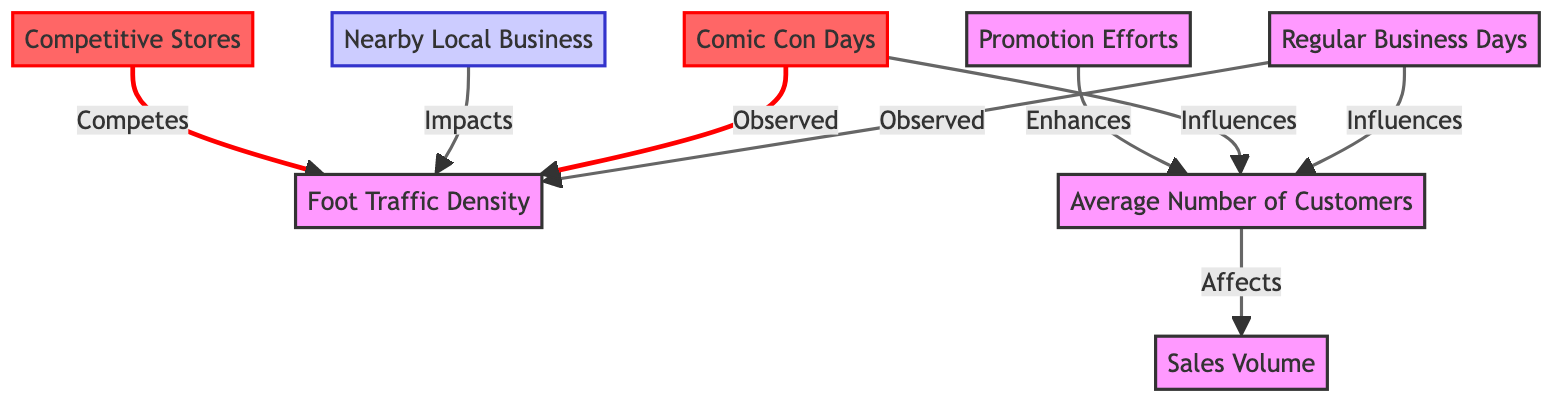What are the two main categories of days illustrated in the diagram? The diagram clearly distinguishes between "Regular Business Days" and "Comic Con Days" as the main categories affecting foot traffic density. These two nodes are the starting points that influence other aspects in the diagram.
Answer: Regular Business Days, Comic Con Days How many influences does "Regular Business Days" have? In the diagram, "Regular Business Days" has two outgoing influences: one pointing to "Foot Traffic Density" and another pointing to "Avg Customers". Counting these connections gives us a total of two influences.
Answer: 2 What effect does "Promo Efforts" have on "AvgCustomers"? The diagram indicates that "Promo Efforts" enhances "Avg Customers", creating a direct influence relationship where promotional activities potentially increase the average number of customers.
Answer: Enhances Which two nodes compete for "Foot Traffic Density"? The diagram highlights that both "Competitive Stores" and "Nearby Local Business" influence "Foot Traffic Density", but only "Competitive Stores" has a competing relationship. This indicates that they draw foot traffic away from each other.
Answer: Competitive Stores What is the relationship between "Comic Con Days" and "Sales Volume"? Since "Comic Con Days" influences "Avg Customers" and "Avg Customers" directly affects "Sales Volume", we can deduce that "Comic Con Days" ultimately impacts "Sales Volume" through its effect on the average number of customers.
Answer: Influences What color represents Comic Con Days in the diagram? The "Comic Con Days" node is colored in threat red, indicating its significance as a potential threat to regular business operations due to increased competition and foot traffic dynamics.
Answer: Red How many total nodes are represented in the diagram? Counting all individual elements: "Regular Business Days", "Comic Con Days", "Foot Traffic Density", "Avg Customers", "Sales Volume", "Promo Efforts", "Nearby Business", and "Competitive Stores" results in a total of eight nodes.
Answer: 8 